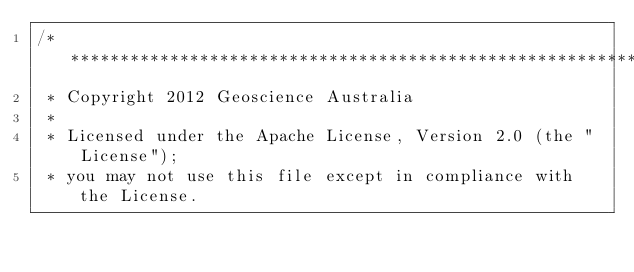<code> <loc_0><loc_0><loc_500><loc_500><_Java_>/*******************************************************************************
 * Copyright 2012 Geoscience Australia
 * 
 * Licensed under the Apache License, Version 2.0 (the "License");
 * you may not use this file except in compliance with the License.</code> 